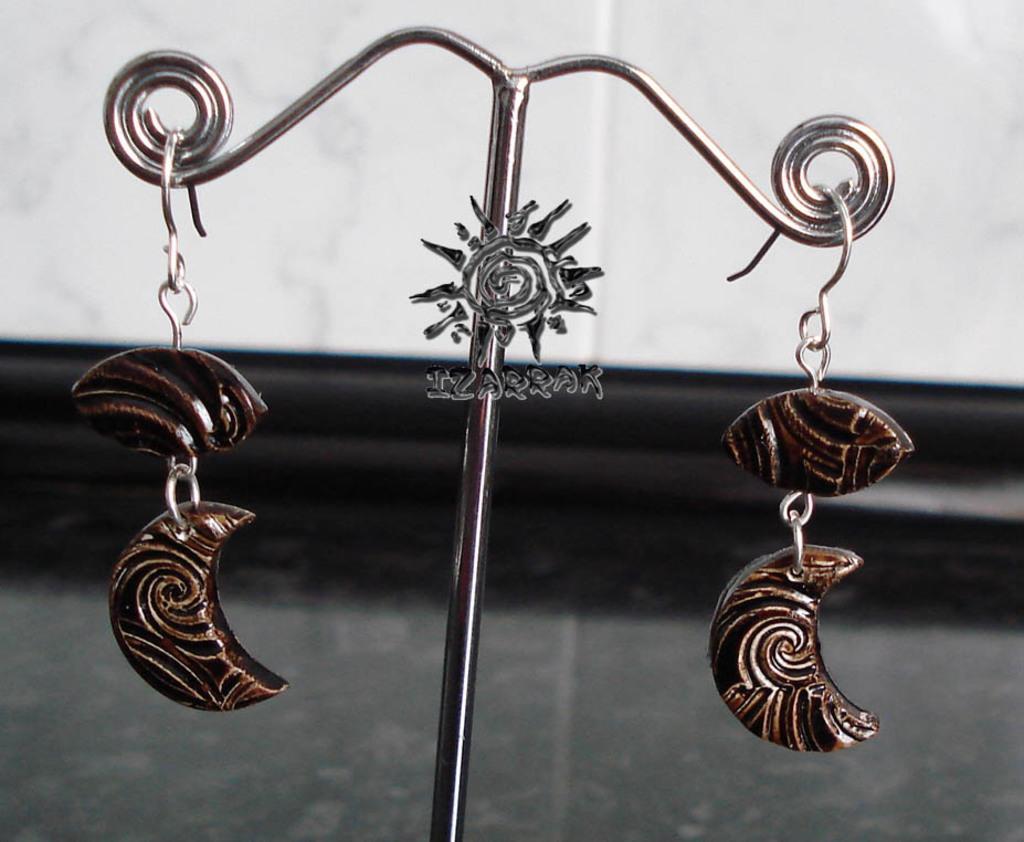Can you describe this image briefly? In this image in the center there is one pole and there are a pair of earrings, in the background there is a wall. 